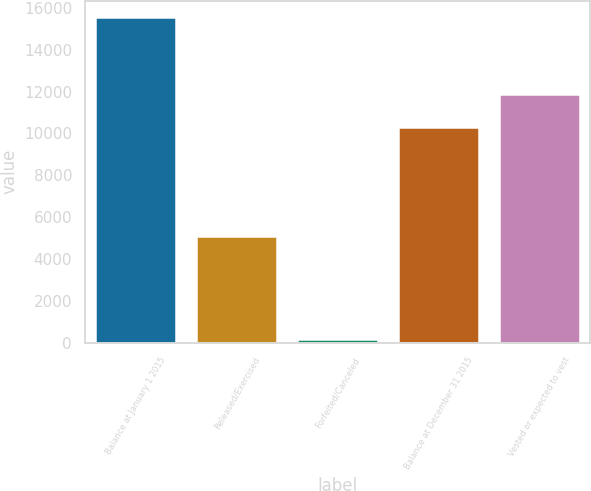Convert chart. <chart><loc_0><loc_0><loc_500><loc_500><bar_chart><fcel>Balance at January 1 2015<fcel>Released/Exercised<fcel>Forfeited/Canceled<fcel>Balance at December 31 2015<fcel>Vested or expected to vest<nl><fcel>15577<fcel>5084<fcel>166<fcel>10327<fcel>11868.1<nl></chart> 